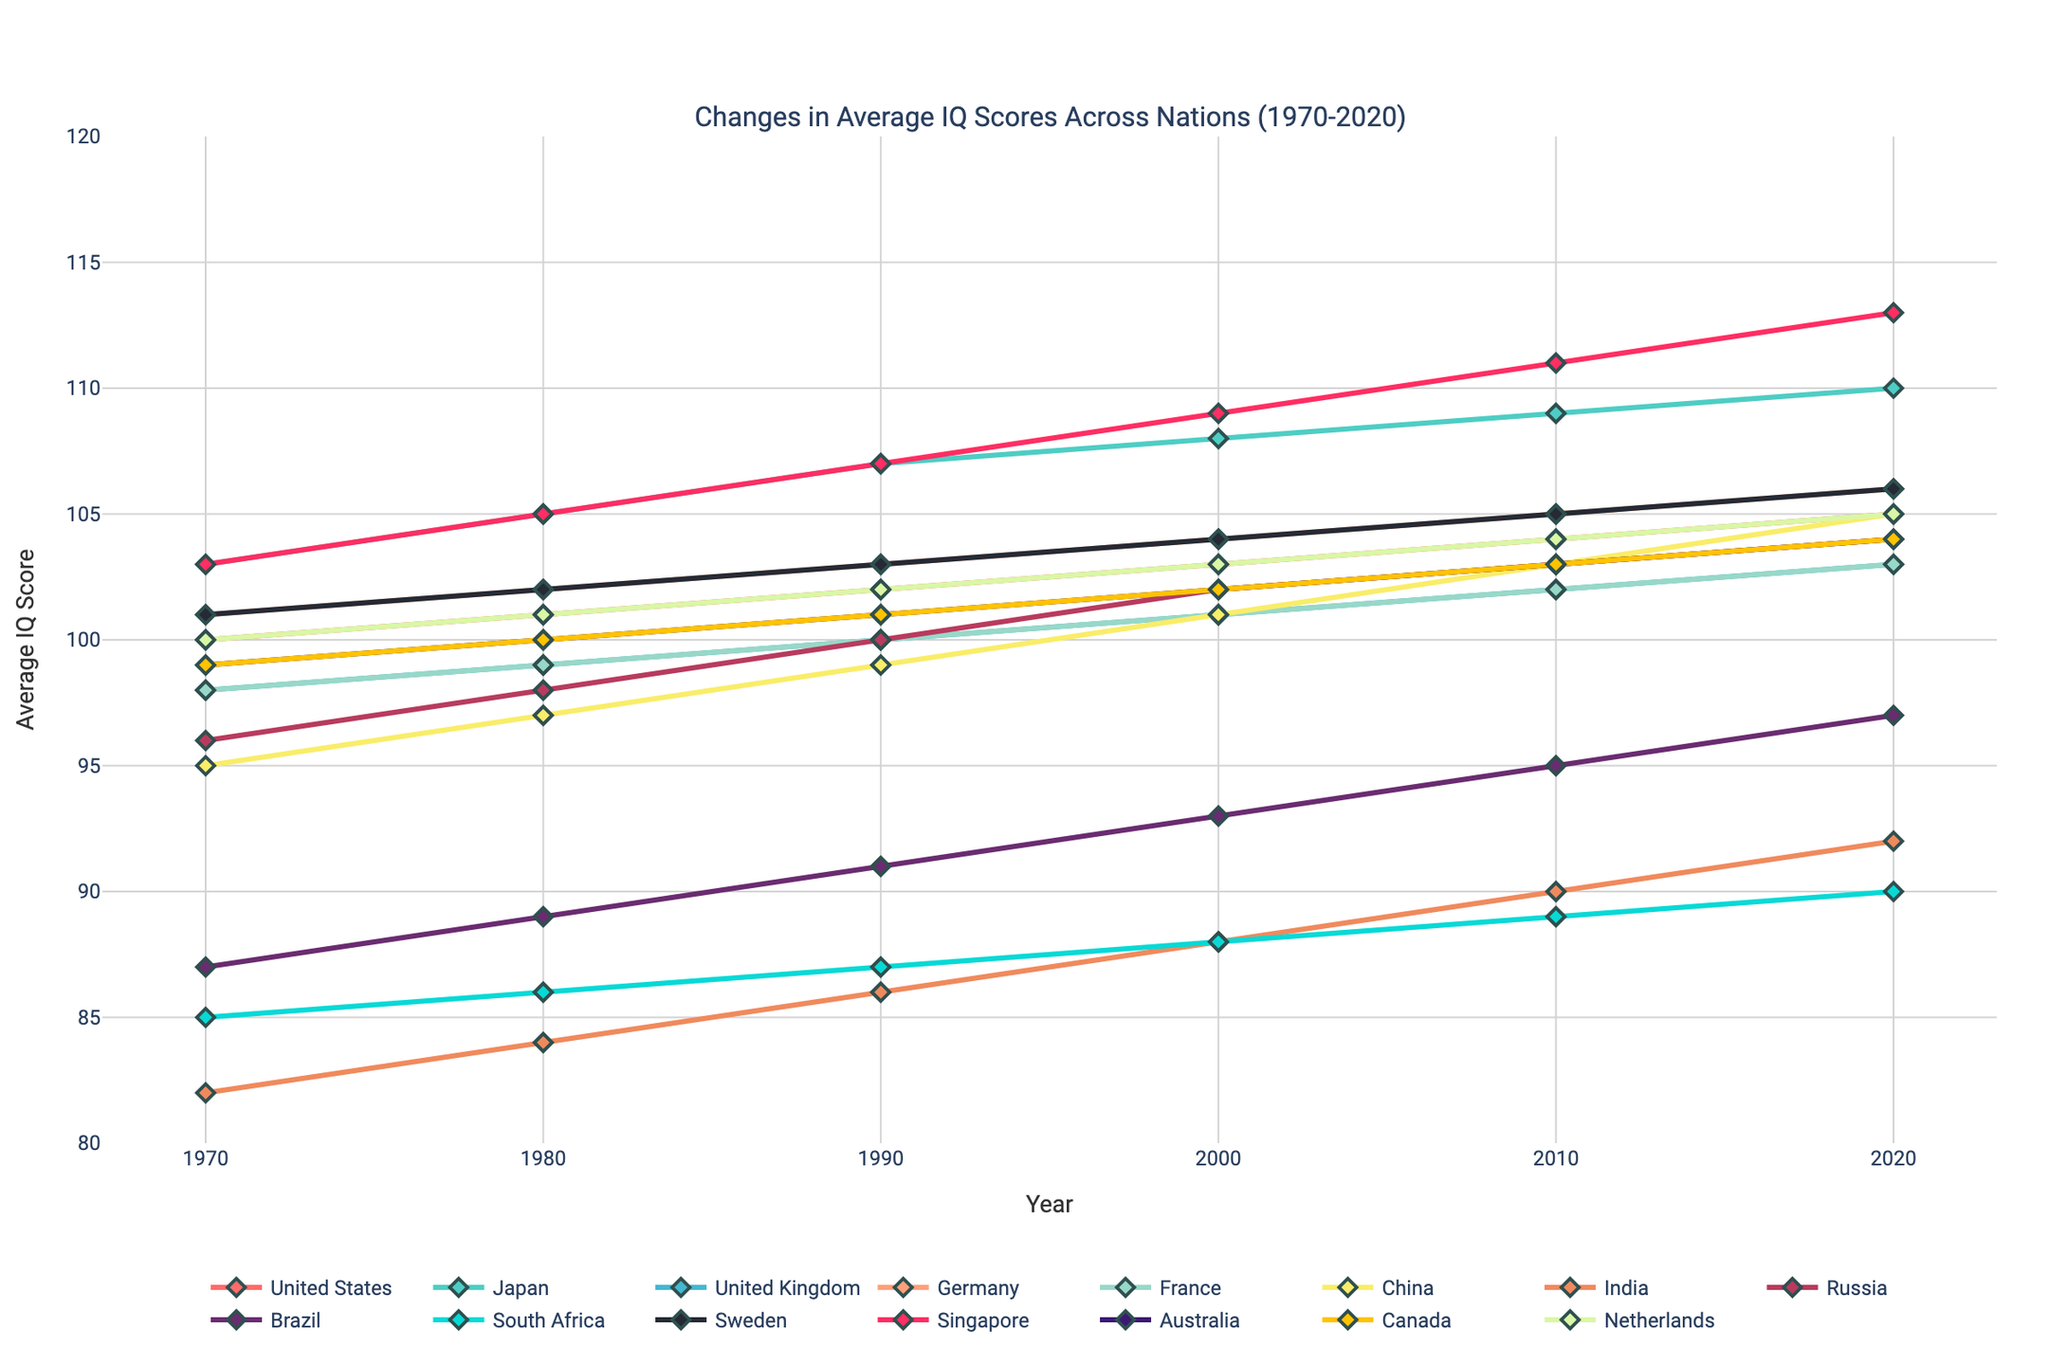How does the average IQ score of China in 2020 compare to Brazil in the same year? China’s average IQ in 2020 is 105, while Brazil's is 97. Subtract 97 from 105 to find the difference, which is 8.
Answer: 8 Which country showed the largest increase in average IQ score from 1970 to 2020? Calculate the difference between 2020 and 1970 for each country and determine which is the largest. Singapore has the largest increase (113 - 103 = 10).
Answer: Singapore What is the average IQ score of Germany over the last 50 years? Add Germany’s IQ scores from 1970 to 2020 (101 + 102 + 103 + 104 + 105 + 106) = 621, then divide by 6 (number of years) to get 621/6.
Answer: 103.5 Which country had the lowest IQ score in 1970, and what was the value? Identify the minimum value in the 1970 column, which is 82 from India.
Answer: India, 82 Consider the IQ scores of Sweden and Canada in 1990; which country had a higher score? Sweden’s IQ in 1990 is 103, and Canada’s is 101. Since 103 is greater than 101, Sweden had the higher score.
Answer: Sweden What is the total increase in IQ score for India from 1970 to 2020? Subtract the 1970 value from the 2020 value for India. That’s 92 - 82 = 10.
Answer: 10 What is the average IQ score across all nations in the year 2000? Add all countries' IQ scores for 2000 (103+108+101+104+101+101+88+102+93+88+104+109+102+102+103=1521) and divide by 15 (number of countries). 1521/15 = 101.4.
Answer: 101.4 Which two countries had the closest average IQ scores in 2010, and what were the scores? Inspect the 2010 column for the smallest difference between any two values, which are France and the UK both having 102.
Answer: France and UK, both 102 By how many points did Russia's average IQ score increase between 1980 and 2000? Subtract the 1980 value from the 2000 value for Russia: 102 - 98 = 4.
Answer: 4 Based on the trends, which country's IQ score is consistently the highest over the years? From the graph, note that Singapore consistently has one of the highest IQ scores and check the values.
Answer: Singapore 